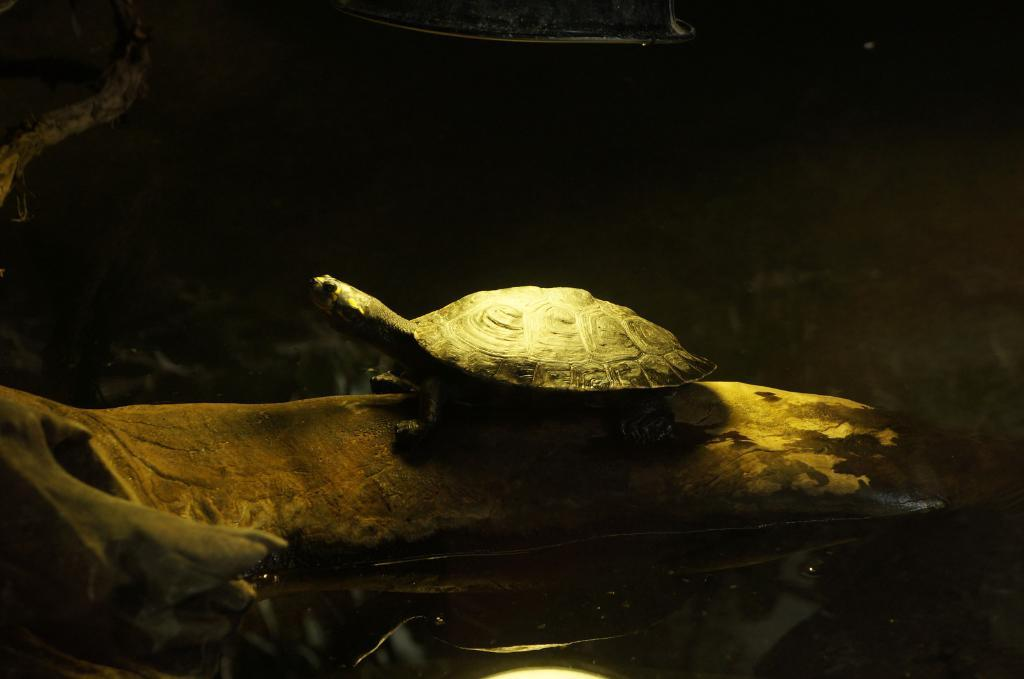What type of animal is in the image? There is a tortoise in the image. Where is the tortoise located? The tortoise is on the surface in the image. What can be seen at the bottom of the image? There is water visible at the bottom of the image. What type of doctor is examining the tortoise in the image? There is no doctor present in the image; it only features a tortoise on the surface and water at the bottom. 